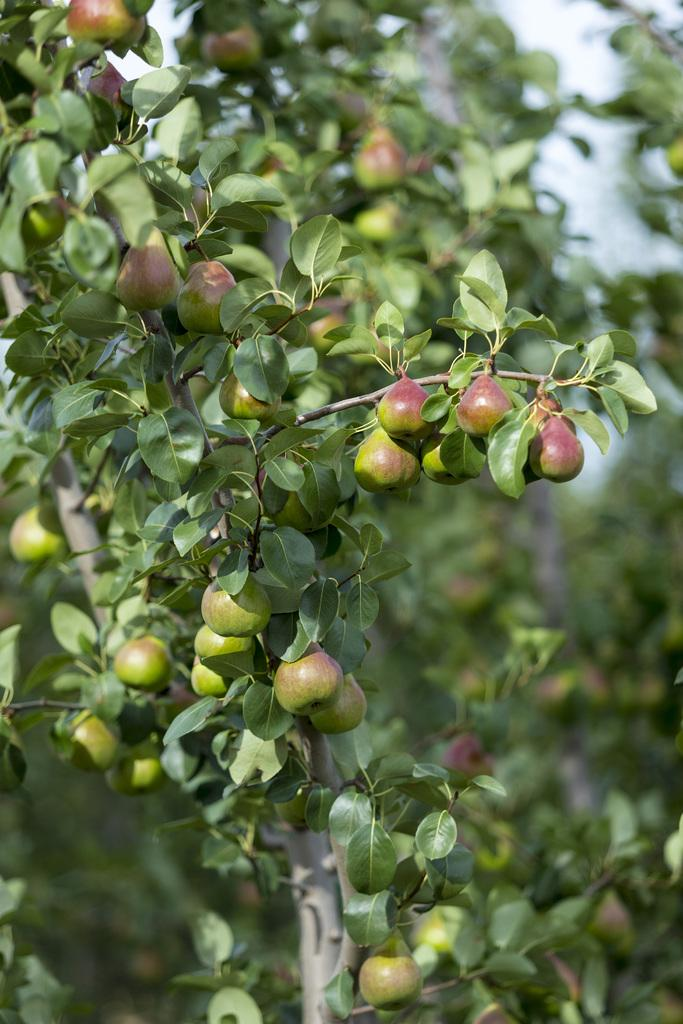What type of vegetation can be seen in the image? There are trees in the image. What is the condition of the trees in the image? The trees have leaves and fruits. How is the background of the image depicted? The background of the image is blurred. Can you see a kite flying in the background of the image? There is no kite visible in the image; the background is blurred and only trees with leaves and fruits are present. 